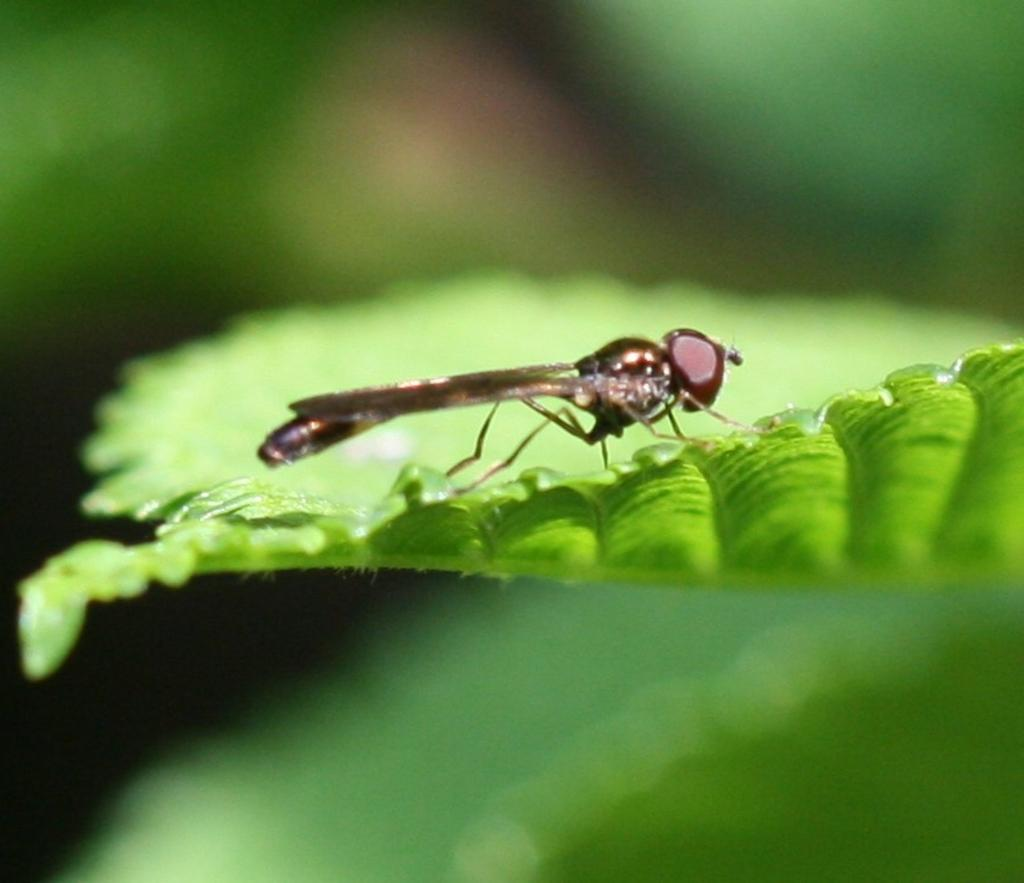What type of creature is in the image? There is an insect in the image. Where is the insect located? The insect is on a leaf. What is the weight of the copper object in the image? There is no copper object present in the image, so it is not possible to determine its weight. 